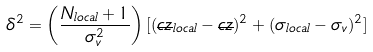Convert formula to latex. <formula><loc_0><loc_0><loc_500><loc_500>\delta ^ { 2 } = \left ( \frac { N _ { l o c a l } + 1 } { \sigma _ { v } ^ { 2 } } \right ) [ ( \overline { c z } _ { l o c a l } - \overline { c z } ) ^ { 2 } + ( \sigma _ { l o c a l } - \sigma _ { v } ) ^ { 2 } ]</formula> 